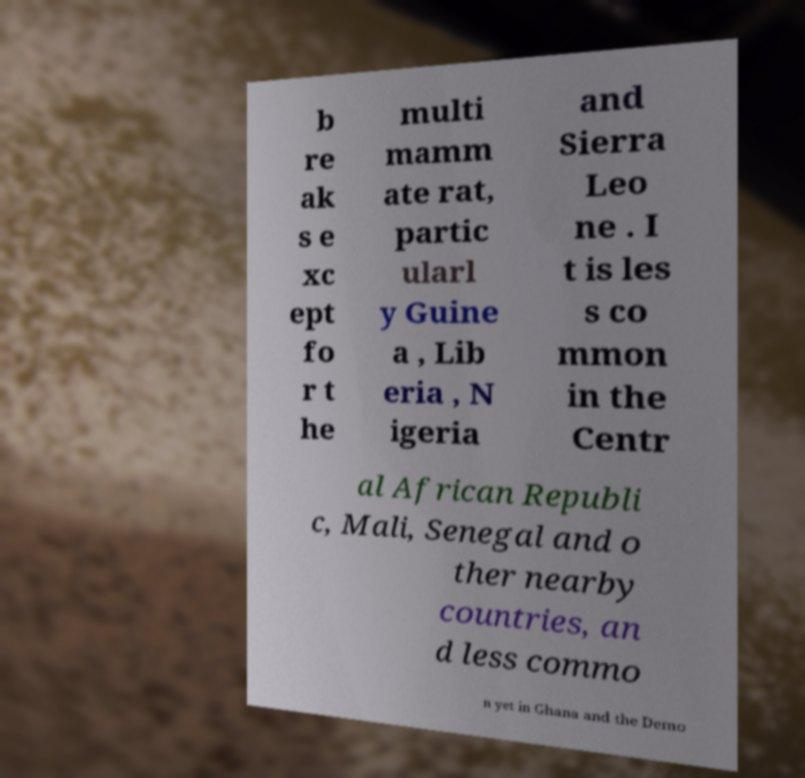Can you read and provide the text displayed in the image?This photo seems to have some interesting text. Can you extract and type it out for me? b re ak s e xc ept fo r t he multi mamm ate rat, partic ularl y Guine a , Lib eria , N igeria and Sierra Leo ne . I t is les s co mmon in the Centr al African Republi c, Mali, Senegal and o ther nearby countries, an d less commo n yet in Ghana and the Demo 